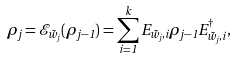Convert formula to latex. <formula><loc_0><loc_0><loc_500><loc_500>\rho _ { j } = \mathcal { E } _ { \tilde { w } _ { j } } ( \rho _ { j - 1 } ) = \sum _ { i = 1 } ^ { k } E _ { \tilde { w } _ { j } , i } \rho _ { j - 1 } E _ { \tilde { w } _ { j } , i } ^ { \dagger } ,</formula> 